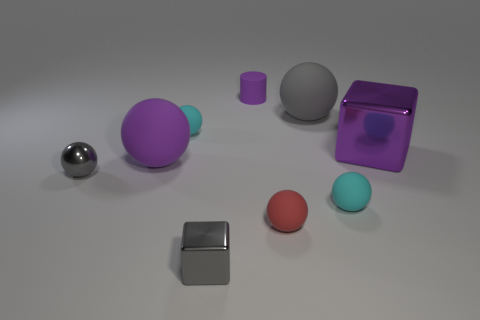Subtract all cyan spheres. How many were subtracted if there are1cyan spheres left? 1 Subtract all large spheres. How many spheres are left? 4 Subtract all cubes. How many objects are left? 7 Add 1 cylinders. How many objects exist? 10 Subtract all cyan spheres. How many spheres are left? 4 Add 5 small brown cylinders. How many small brown cylinders exist? 5 Subtract 0 green cylinders. How many objects are left? 9 Subtract 2 cubes. How many cubes are left? 0 Subtract all green spheres. Subtract all green blocks. How many spheres are left? 6 Subtract all green blocks. How many gray cylinders are left? 0 